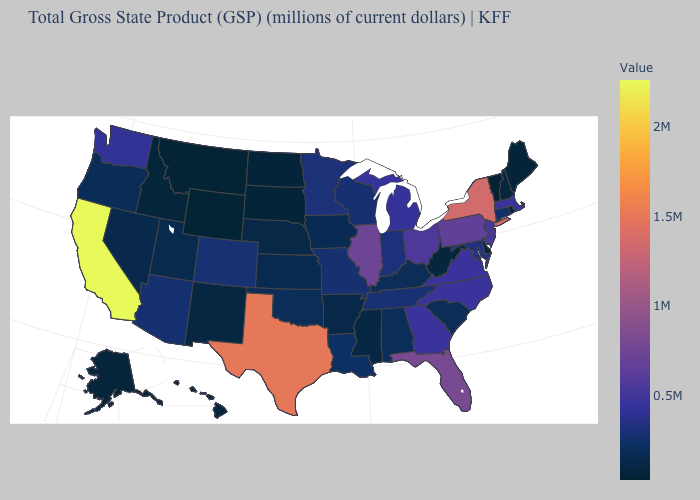Does New Jersey have a lower value than New York?
Be succinct. Yes. Among the states that border Pennsylvania , which have the highest value?
Keep it brief. New York. Is the legend a continuous bar?
Give a very brief answer. Yes. Which states have the highest value in the USA?
Quick response, please. California. 